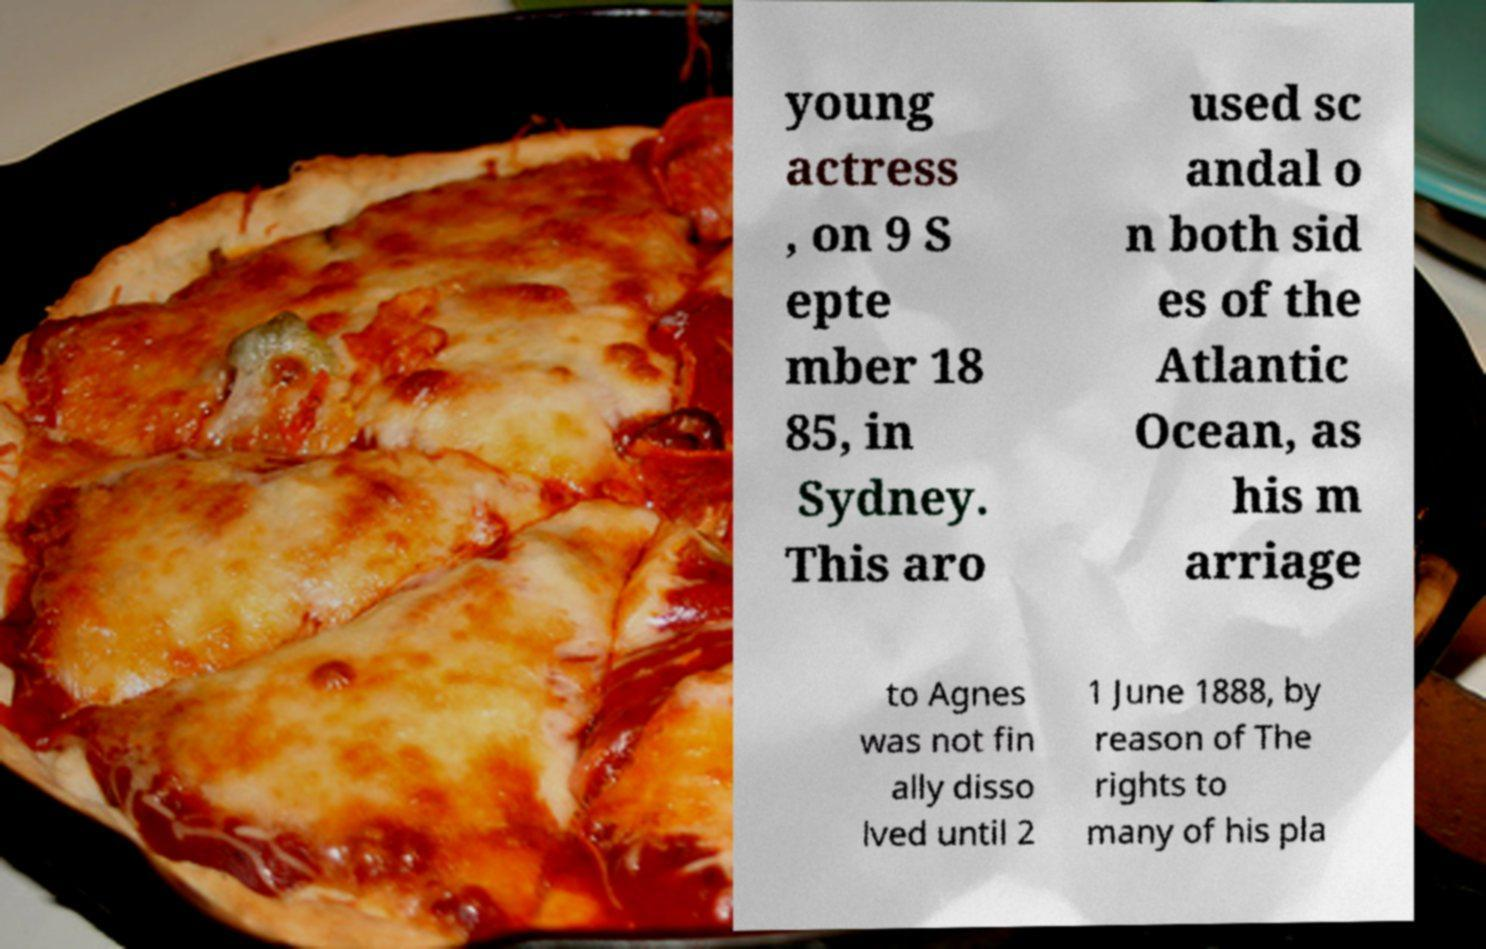Can you read and provide the text displayed in the image?This photo seems to have some interesting text. Can you extract and type it out for me? young actress , on 9 S epte mber 18 85, in Sydney. This aro used sc andal o n both sid es of the Atlantic Ocean, as his m arriage to Agnes was not fin ally disso lved until 2 1 June 1888, by reason of The rights to many of his pla 